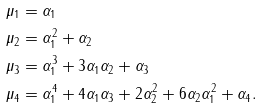Convert formula to latex. <formula><loc_0><loc_0><loc_500><loc_500>\mu _ { 1 } & = \alpha _ { 1 } \\ \mu _ { 2 } & = \alpha _ { 1 } ^ { 2 } + \alpha _ { 2 } \\ \mu _ { 3 } & = \alpha _ { 1 } ^ { 3 } + 3 \alpha _ { 1 } \alpha _ { 2 } + \alpha _ { 3 } \\ \mu _ { 4 } & = \alpha _ { 1 } ^ { 4 } + 4 \alpha _ { 1 } \alpha _ { 3 } + 2 \alpha _ { 2 } ^ { 2 } + 6 \alpha _ { 2 } \alpha _ { 1 } ^ { 2 } + \alpha _ { 4 } .</formula> 